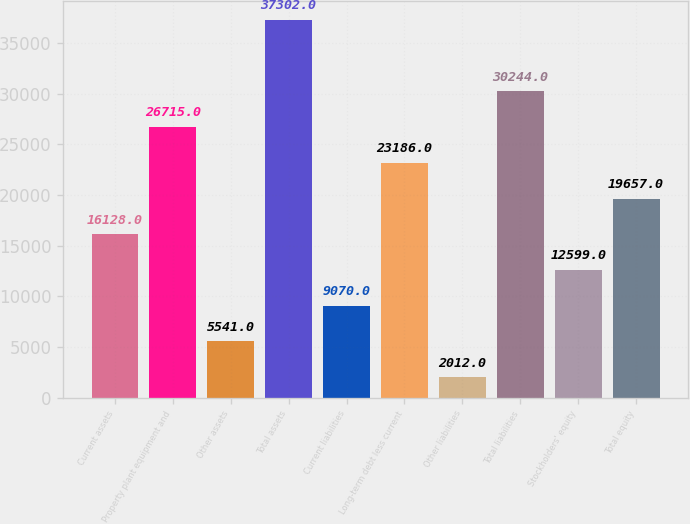<chart> <loc_0><loc_0><loc_500><loc_500><bar_chart><fcel>Current assets<fcel>Property plant equipment and<fcel>Other assets<fcel>Total assets<fcel>Current liabilities<fcel>Long-term debt less current<fcel>Other liabilities<fcel>Total liabilities<fcel>Stockholders' equity<fcel>Total equity<nl><fcel>16128<fcel>26715<fcel>5541<fcel>37302<fcel>9070<fcel>23186<fcel>2012<fcel>30244<fcel>12599<fcel>19657<nl></chart> 